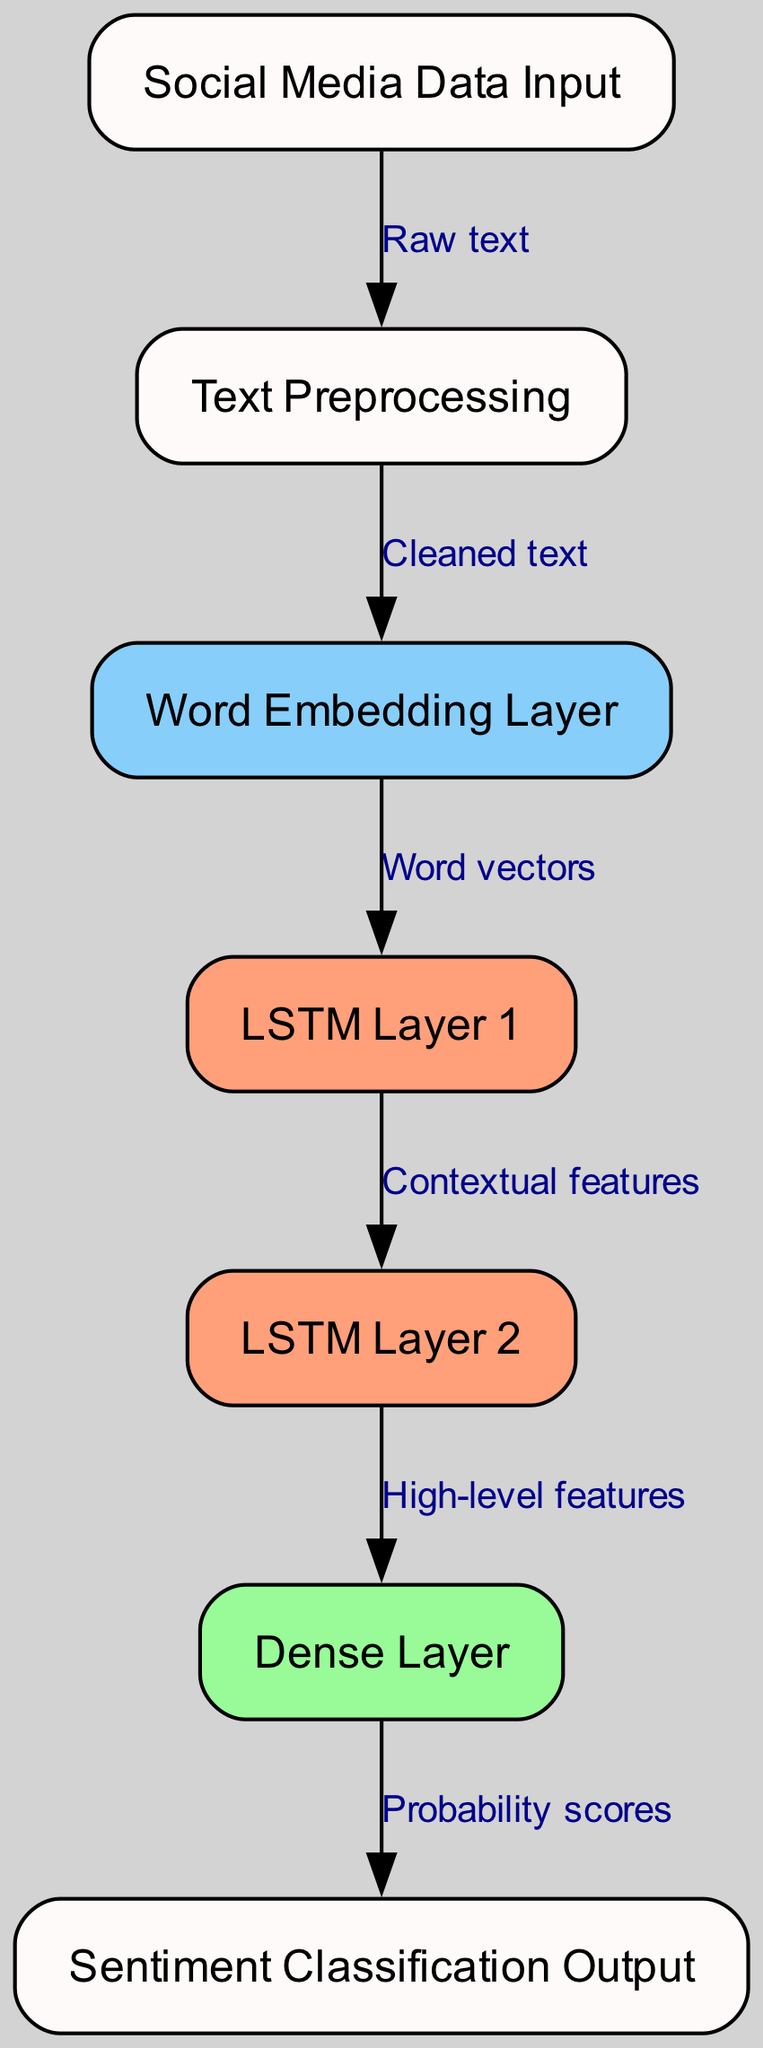What is the first step in the process? The first node in the diagram is labeled "Social Media Data Input," which indicates that the process starts with raw social media data.
Answer: Social Media Data Input How many layers are in the network after embedding? Counting the nodes after the "Word Embedding Layer," there are two LSTM layers and one Dense layer, totaling three layers.
Answer: Three layers What does the output layer represent? The final node in the diagram is labeled "Sentiment Classification Output," which indicates that the output layer classifies the processed sentiment.
Answer: Sentiment Classification Output What type of data is fed into the LSTM Layer 1? LSTM Layer 1 receives "Word vectors," which are the processed input from the preceding "Word Embedding Layer."
Answer: Word vectors How many edges connect the Dense Layer to the output? There is a single edge from the Dense Layer to the output node, indicating a direct connection.
Answer: One edge What type of features are passed from LSTM Layer 2 to the Dense Layer? The connection from LSTM Layer 2 to the Dense Layer is labeled "High-level features," showing the type of information being passed.
Answer: High-level features Which step involves cleaning the text data? The node labeled "Text Preprocessing" is identified as the step for cleaning the raw social media text data before further processing.
Answer: Text Preprocessing What is the main purpose of the Word Embedding Layer? The purpose of the Word Embedding Layer is to convert cleaned text into "Word vectors," which provide numerical representations for processing.
Answer: Word vectors What is the relationship between LSTM Layer 1 and LSTM Layer 2? The edge between LSTM Layer 1 and LSTM Layer 2 is labeled "Contextual features," indicating that the latter receives features that capture context from the former.
Answer: Contextual features 